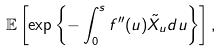<formula> <loc_0><loc_0><loc_500><loc_500>\mathbb { E } \left [ \exp \left \{ - \int _ { 0 } ^ { s } f ^ { \prime \prime } ( u ) \tilde { X } _ { u } d u \right \} \right ] ,</formula> 